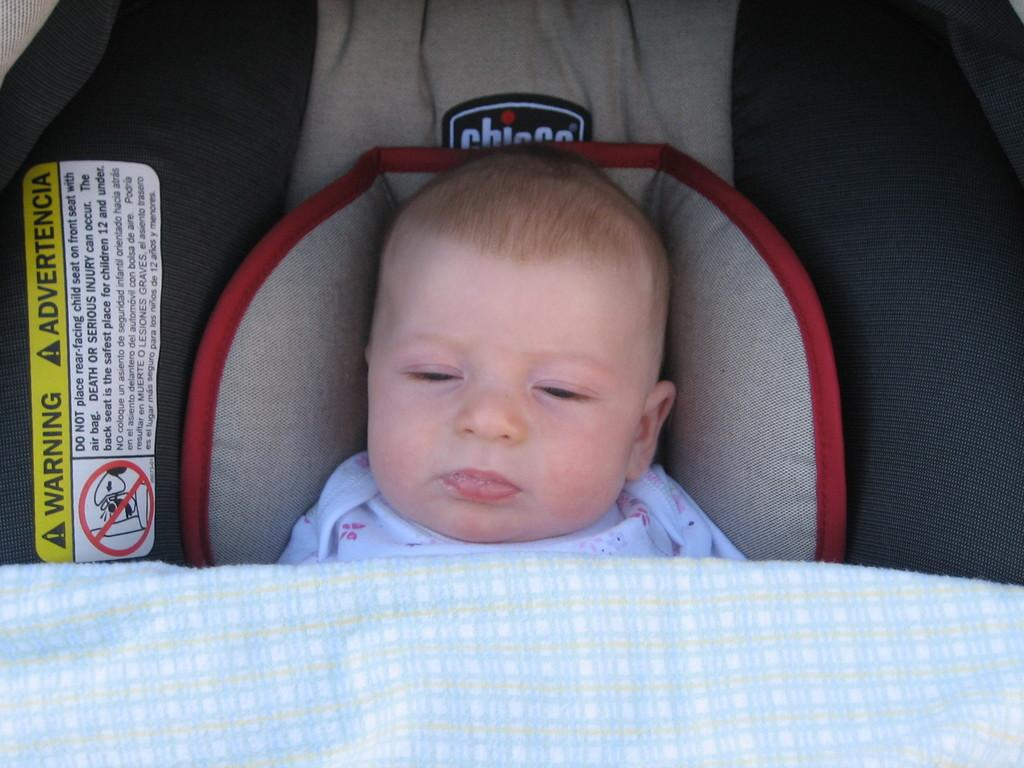What is the main subject of the image? The main subject of the image is a baby. Where is the baby located in the image? The baby is laying under a baby cradle. Can you describe any additional features of the baby cradle? There is a caution sticker on the left side of the baby cradle. What type of mass is being suggested in the image? There is no mass or suggestion of a mass in the image; it features a baby laying under a baby cradle with a caution sticker. Can you describe the comb used by the baby in the image? There is no comb present in the image; the baby is laying under a baby cradle. 